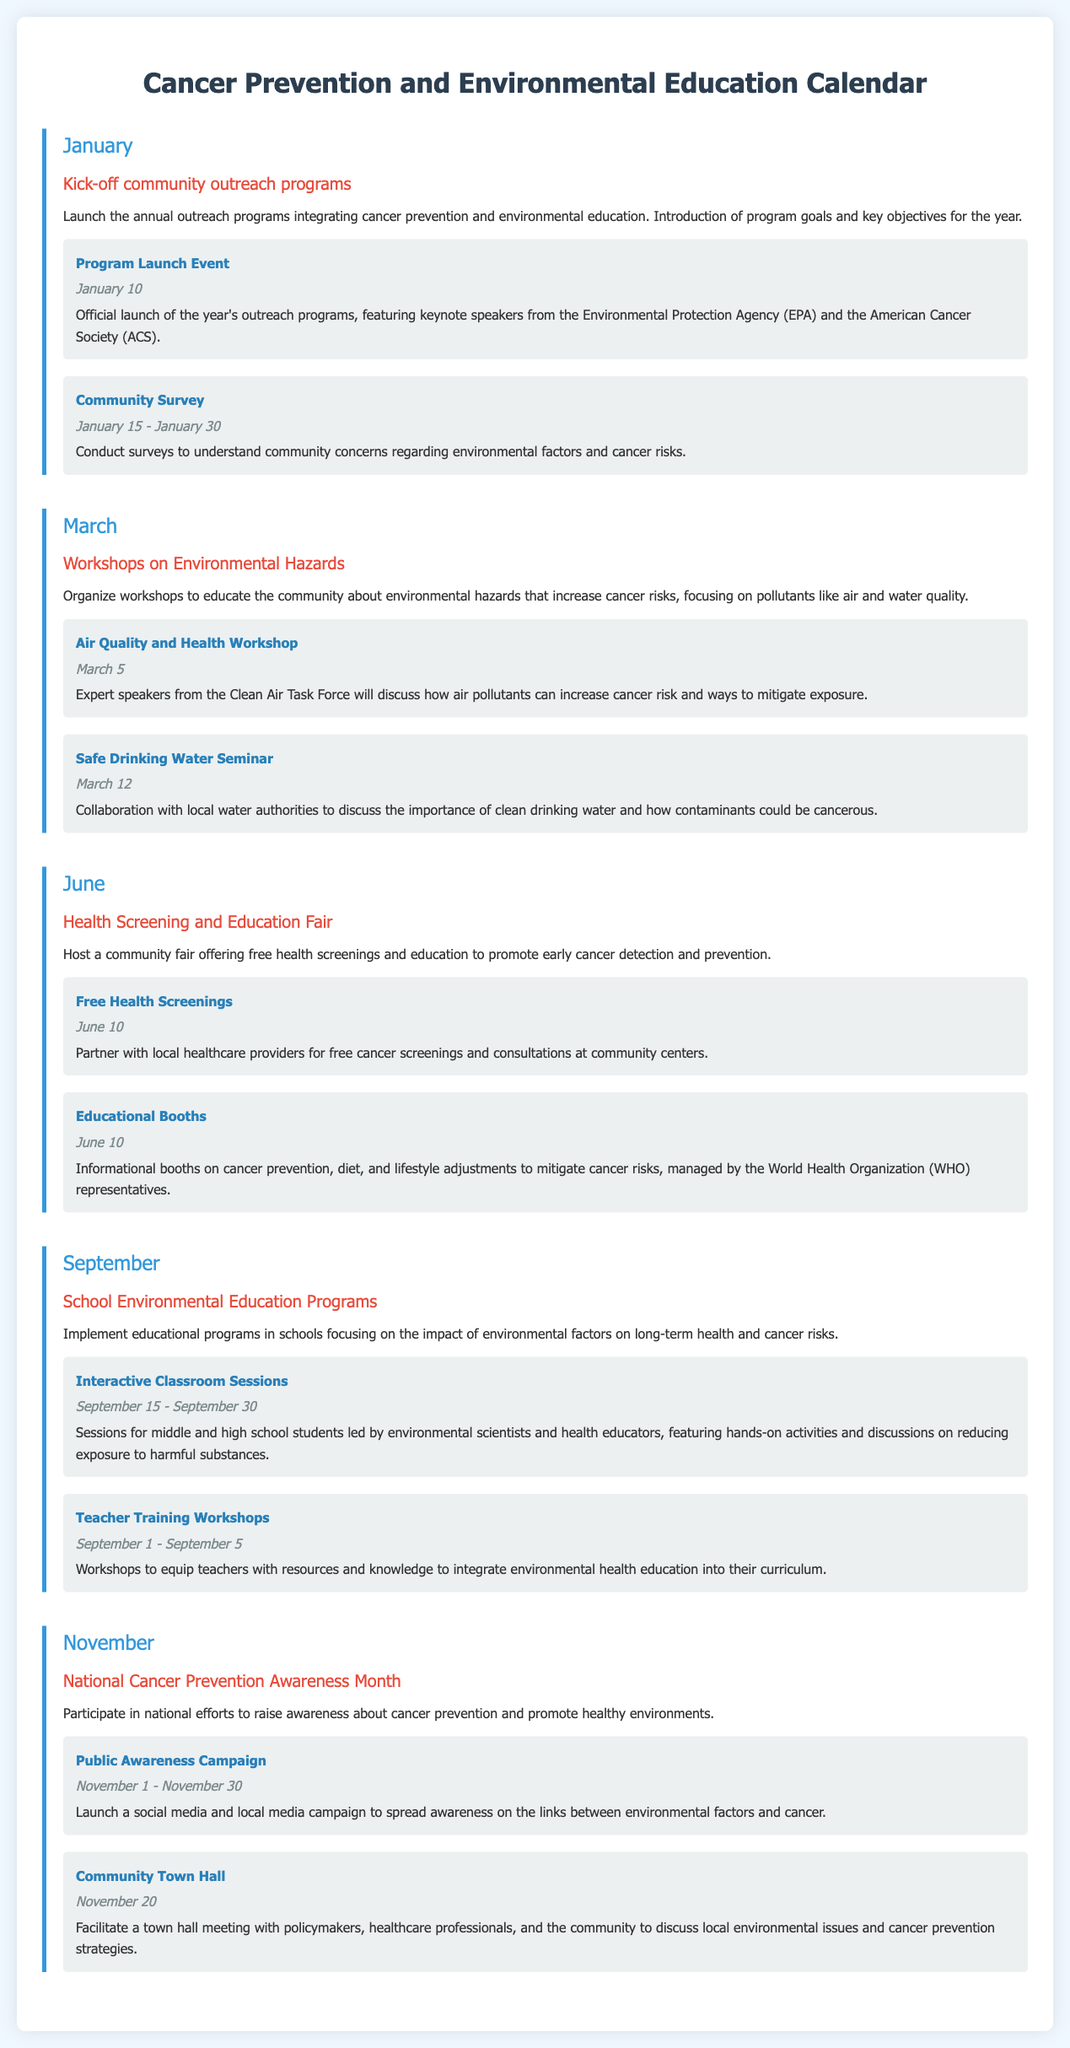what is the date of the Program Launch Event? The Program Launch Event is mentioned under January, and its date is specified in the document.
Answer: January 10 what is the purpose of the community survey? The community survey is detailed under the January milestone and discusses the aims to understand community concerns related to environmental factors and cancer risks.
Answer: Understand community concerns which month hosts the Health Screening and Education Fair? The Health Screening and Education Fair is highlighted in the June milestone section of the document.
Answer: June how many events are scheduled in November? The document lists the events under the National Cancer Prevention Awareness Month milestone, and the number of events is clearly stated.
Answer: 2 what is one of the focuses of the workshops in March? The workshops scheduled in March primarily focus on educating the community about environmental hazards related to increasing cancer risks.
Answer: Environmental hazards who will discuss air pollutants at the Air Quality and Health Workshop? The event description for the Air Quality and Health Workshop specifies that expert speakers from the Clean Air Task Force will be involved.
Answer: Clean Air Task Force what two groups are collaborating in the Safe Drinking Water Seminar? The Safe Drinking Water Seminar describes a collaboration between local water authorities and the outreach program to address the importance of clean drinking water.
Answer: local water authorities what kind of sessions will occur between September 15 - September 30? The document specifies that there will be interactive classroom sessions for middle and high school students within these dates.
Answer: Interactive Classroom Sessions what is the description of the Public Awareness Campaign? The description of the Public Awareness Campaign indicated in November details its aim to raise awareness on the links between environmental factors and cancer.
Answer: Social media and local media campaign 